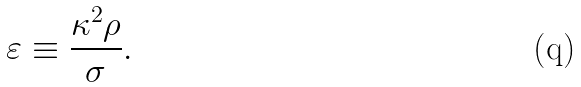Convert formula to latex. <formula><loc_0><loc_0><loc_500><loc_500>\varepsilon \equiv \frac { \kappa ^ { 2 } \rho } { \sigma } .</formula> 